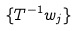<formula> <loc_0><loc_0><loc_500><loc_500>\{ T ^ { - 1 } w _ { j } \}</formula> 